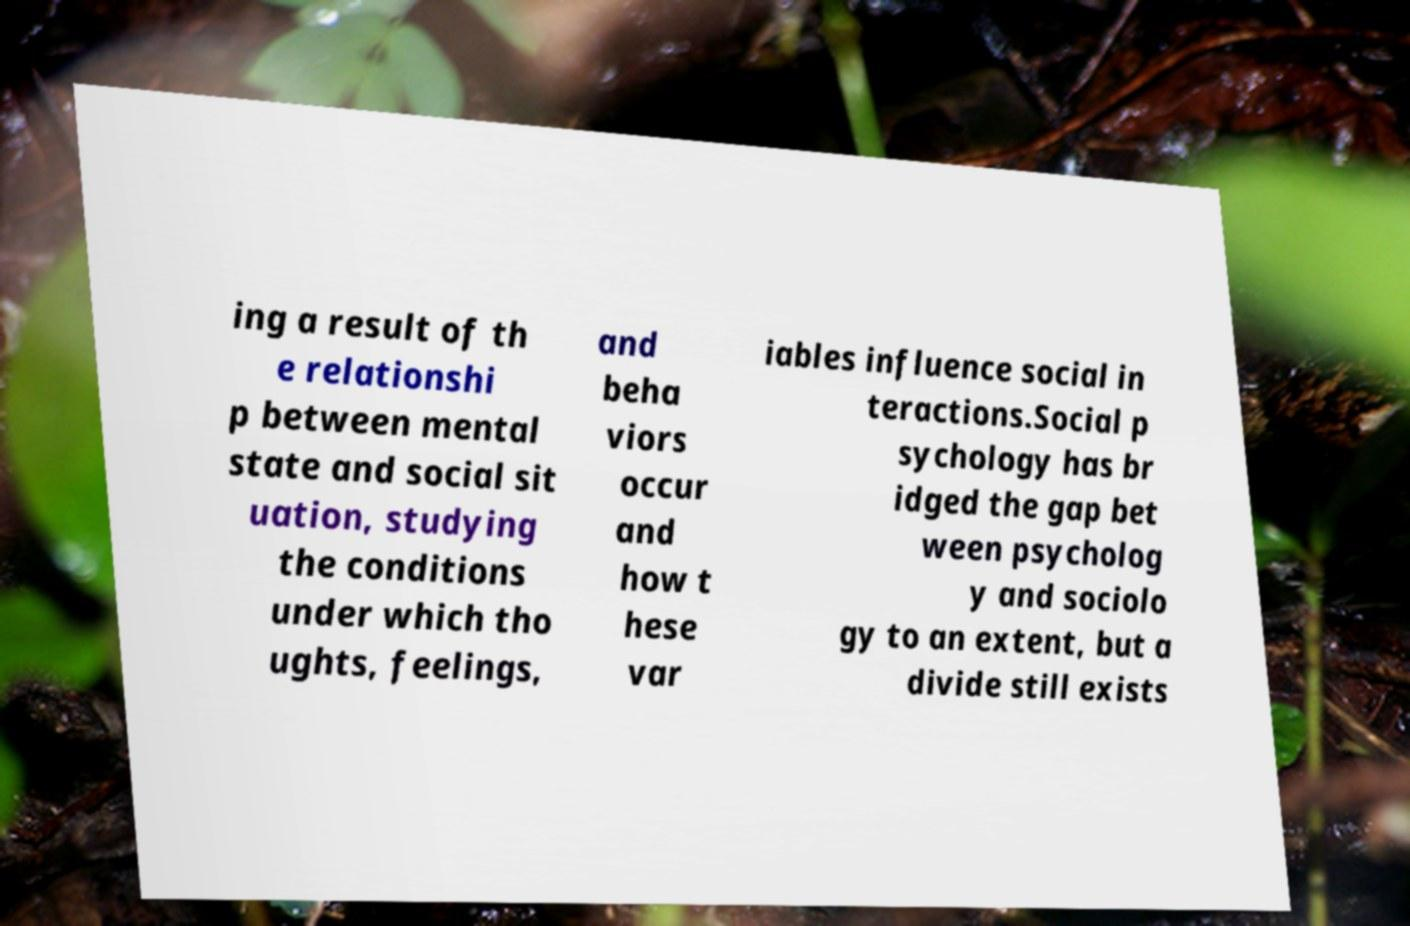Could you extract and type out the text from this image? ing a result of th e relationshi p between mental state and social sit uation, studying the conditions under which tho ughts, feelings, and beha viors occur and how t hese var iables influence social in teractions.Social p sychology has br idged the gap bet ween psycholog y and sociolo gy to an extent, but a divide still exists 